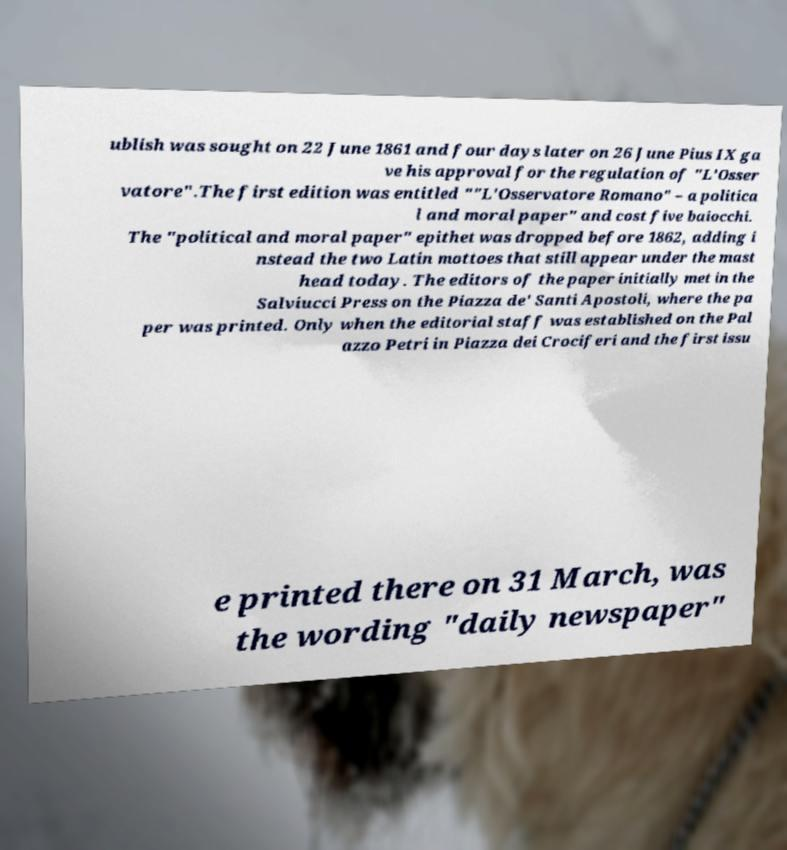Can you accurately transcribe the text from the provided image for me? ublish was sought on 22 June 1861 and four days later on 26 June Pius IX ga ve his approval for the regulation of "L'Osser vatore".The first edition was entitled ""L'Osservatore Romano" – a politica l and moral paper" and cost five baiocchi. The "political and moral paper" epithet was dropped before 1862, adding i nstead the two Latin mottoes that still appear under the mast head today. The editors of the paper initially met in the Salviucci Press on the Piazza de' Santi Apostoli, where the pa per was printed. Only when the editorial staff was established on the Pal azzo Petri in Piazza dei Crociferi and the first issu e printed there on 31 March, was the wording "daily newspaper" 